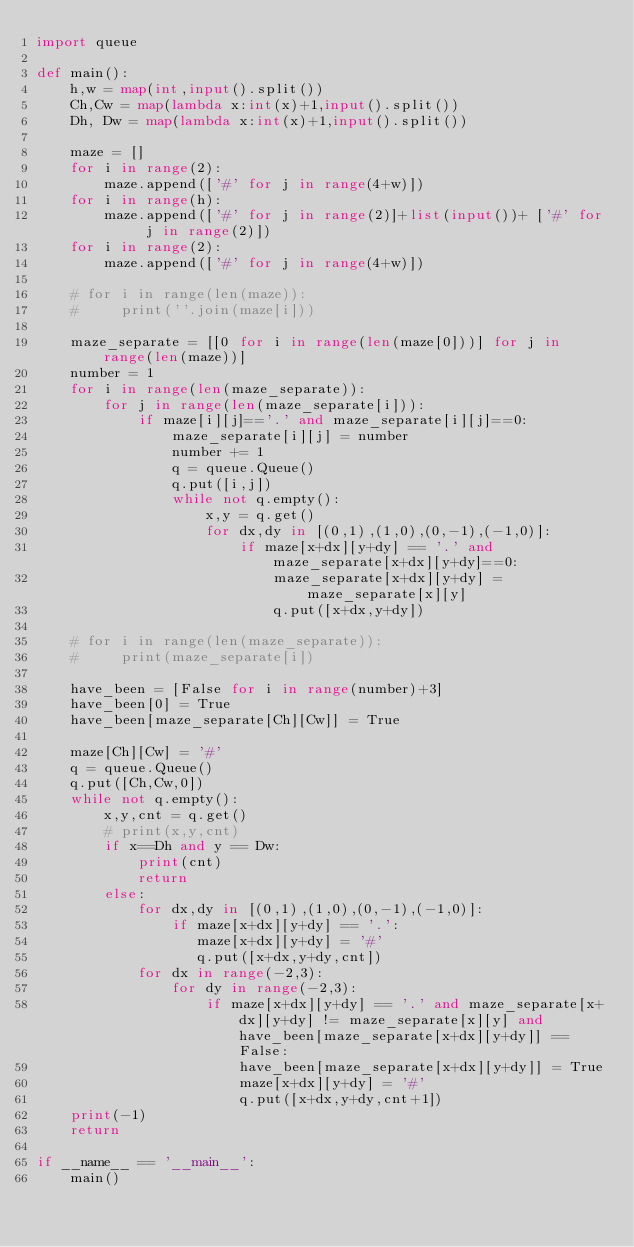<code> <loc_0><loc_0><loc_500><loc_500><_Python_>import queue

def main():
    h,w = map(int,input().split())
    Ch,Cw = map(lambda x:int(x)+1,input().split())
    Dh, Dw = map(lambda x:int(x)+1,input().split())

    maze = []
    for i in range(2):
        maze.append(['#' for j in range(4+w)])
    for i in range(h):
        maze.append(['#' for j in range(2)]+list(input())+ ['#' for j in range(2)])
    for i in range(2):
        maze.append(['#' for j in range(4+w)])

    # for i in range(len(maze)):
    #     print(''.join(maze[i]))

    maze_separate = [[0 for i in range(len(maze[0]))] for j in range(len(maze))]
    number = 1
    for i in range(len(maze_separate)):
        for j in range(len(maze_separate[i])):
            if maze[i][j]=='.' and maze_separate[i][j]==0:
                maze_separate[i][j] = number
                number += 1
                q = queue.Queue()
                q.put([i,j])
                while not q.empty():
                    x,y = q.get()
                    for dx,dy in [(0,1),(1,0),(0,-1),(-1,0)]:
                        if maze[x+dx][y+dy] == '.' and maze_separate[x+dx][y+dy]==0:
                            maze_separate[x+dx][y+dy] = maze_separate[x][y]
                            q.put([x+dx,y+dy])

    # for i in range(len(maze_separate)):
    #     print(maze_separate[i])

    have_been = [False for i in range(number)+3]
    have_been[0] = True
    have_been[maze_separate[Ch][Cw]] = True

    maze[Ch][Cw] = '#'
    q = queue.Queue()
    q.put([Ch,Cw,0])
    while not q.empty():
        x,y,cnt = q.get()
        # print(x,y,cnt)
        if x==Dh and y == Dw:
            print(cnt)
            return 
        else:
            for dx,dy in [(0,1),(1,0),(0,-1),(-1,0)]:
                if maze[x+dx][y+dy] == '.':
                   maze[x+dx][y+dy] = '#'
                   q.put([x+dx,y+dy,cnt]) 
            for dx in range(-2,3):
                for dy in range(-2,3):
                    if maze[x+dx][y+dy] == '.' and maze_separate[x+dx][y+dy] != maze_separate[x][y] and have_been[maze_separate[x+dx][y+dy]] == False:
                        have_been[maze_separate[x+dx][y+dy]] = True
                        maze[x+dx][y+dy] = '#'
                        q.put([x+dx,y+dy,cnt+1]) 
    print(-1)
    return

if __name__ == '__main__':
    main()</code> 